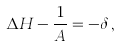Convert formula to latex. <formula><loc_0><loc_0><loc_500><loc_500>\Delta H - \frac { 1 } { A } = - \delta \, ,</formula> 